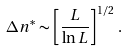<formula> <loc_0><loc_0><loc_500><loc_500>\Delta n ^ { * } \sim \left [ \frac { L } { \ln L } \right ] ^ { 1 / 2 } \, .</formula> 